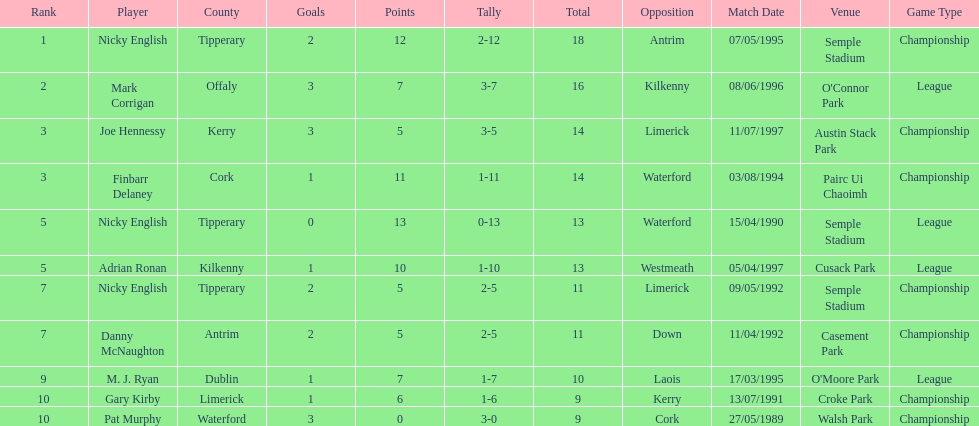Who ranked above mark corrigan? Nicky English. 